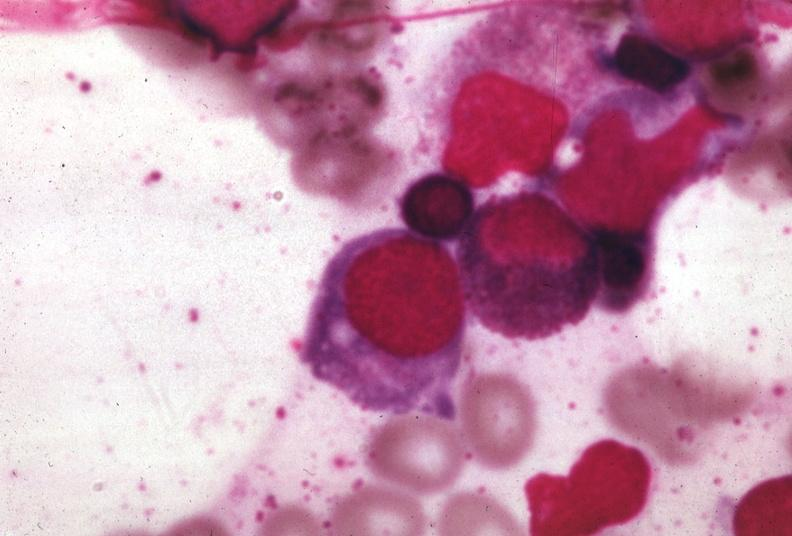what is present?
Answer the question using a single word or phrase. Hematologic 